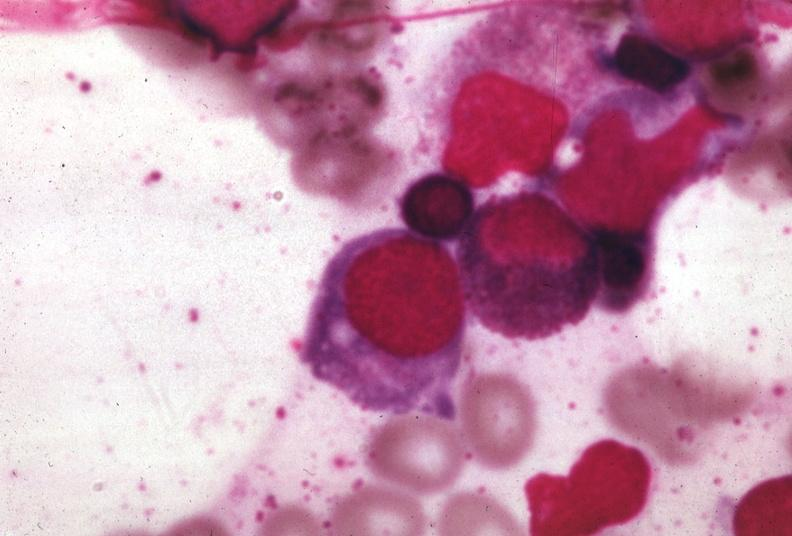what is present?
Answer the question using a single word or phrase. Hematologic 